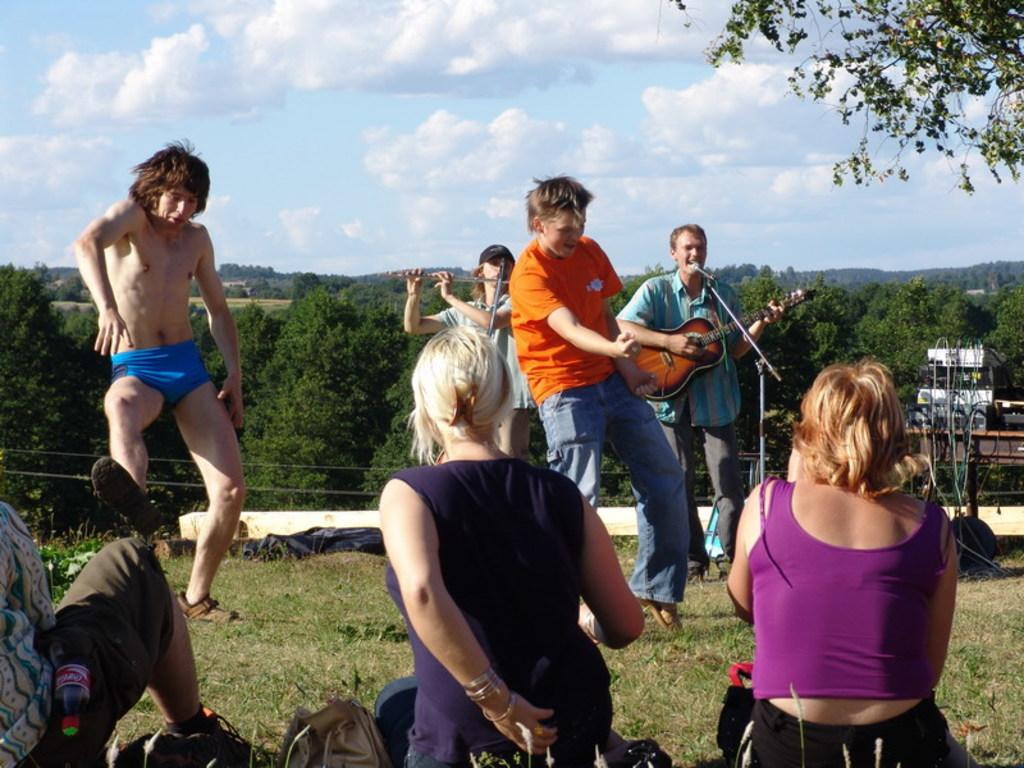How many people are present in the image? There are four people standing and three people sitting in the image, making a total of seven people. What are two of the people doing in the image? Two people are playing musical instruments, and two people are dancing. What can be seen in the background of the image? Trees are visible in the image, and the sky is clear. What type of ornament is hanging from the tree in the image? There is no ornament hanging from the tree in the image; only trees are visible in the background. 